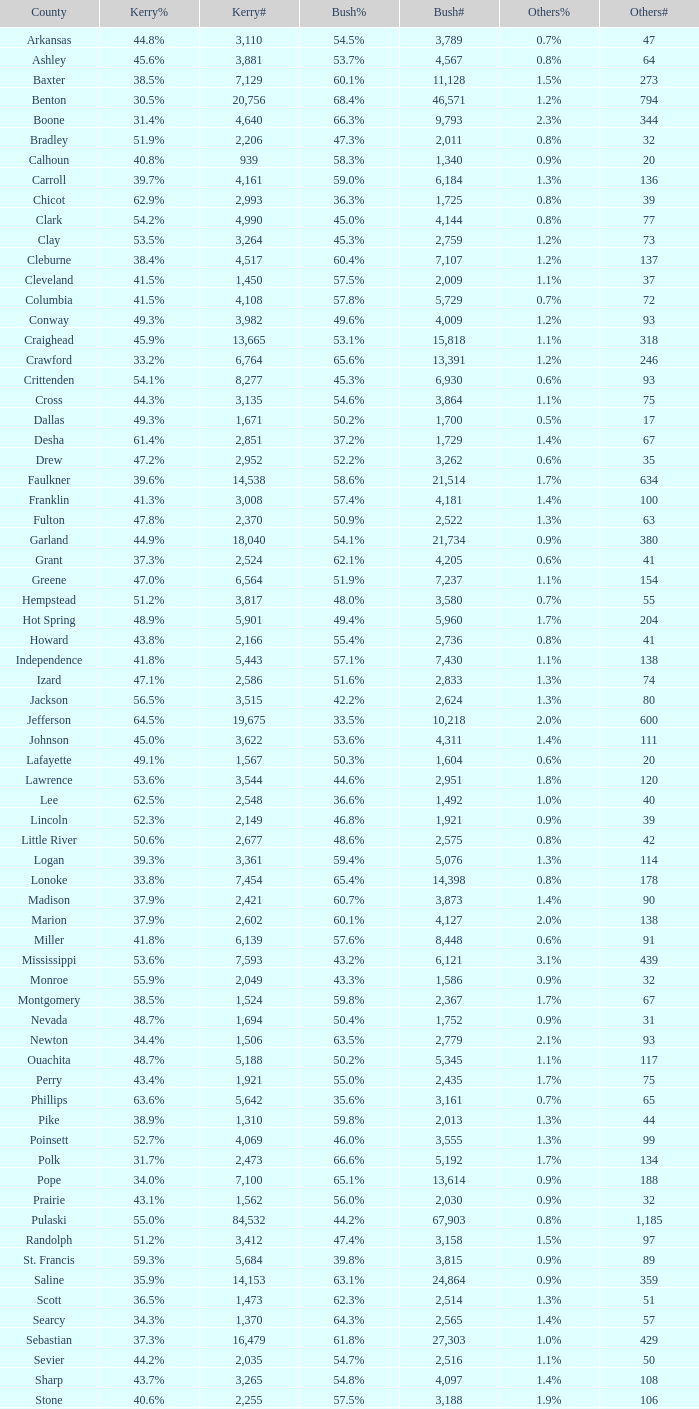Would you mind parsing the complete table? {'header': ['County', 'Kerry%', 'Kerry#', 'Bush%', 'Bush#', 'Others%', 'Others#'], 'rows': [['Arkansas', '44.8%', '3,110', '54.5%', '3,789', '0.7%', '47'], ['Ashley', '45.6%', '3,881', '53.7%', '4,567', '0.8%', '64'], ['Baxter', '38.5%', '7,129', '60.1%', '11,128', '1.5%', '273'], ['Benton', '30.5%', '20,756', '68.4%', '46,571', '1.2%', '794'], ['Boone', '31.4%', '4,640', '66.3%', '9,793', '2.3%', '344'], ['Bradley', '51.9%', '2,206', '47.3%', '2,011', '0.8%', '32'], ['Calhoun', '40.8%', '939', '58.3%', '1,340', '0.9%', '20'], ['Carroll', '39.7%', '4,161', '59.0%', '6,184', '1.3%', '136'], ['Chicot', '62.9%', '2,993', '36.3%', '1,725', '0.8%', '39'], ['Clark', '54.2%', '4,990', '45.0%', '4,144', '0.8%', '77'], ['Clay', '53.5%', '3,264', '45.3%', '2,759', '1.2%', '73'], ['Cleburne', '38.4%', '4,517', '60.4%', '7,107', '1.2%', '137'], ['Cleveland', '41.5%', '1,450', '57.5%', '2,009', '1.1%', '37'], ['Columbia', '41.5%', '4,108', '57.8%', '5,729', '0.7%', '72'], ['Conway', '49.3%', '3,982', '49.6%', '4,009', '1.2%', '93'], ['Craighead', '45.9%', '13,665', '53.1%', '15,818', '1.1%', '318'], ['Crawford', '33.2%', '6,764', '65.6%', '13,391', '1.2%', '246'], ['Crittenden', '54.1%', '8,277', '45.3%', '6,930', '0.6%', '93'], ['Cross', '44.3%', '3,135', '54.6%', '3,864', '1.1%', '75'], ['Dallas', '49.3%', '1,671', '50.2%', '1,700', '0.5%', '17'], ['Desha', '61.4%', '2,851', '37.2%', '1,729', '1.4%', '67'], ['Drew', '47.2%', '2,952', '52.2%', '3,262', '0.6%', '35'], ['Faulkner', '39.6%', '14,538', '58.6%', '21,514', '1.7%', '634'], ['Franklin', '41.3%', '3,008', '57.4%', '4,181', '1.4%', '100'], ['Fulton', '47.8%', '2,370', '50.9%', '2,522', '1.3%', '63'], ['Garland', '44.9%', '18,040', '54.1%', '21,734', '0.9%', '380'], ['Grant', '37.3%', '2,524', '62.1%', '4,205', '0.6%', '41'], ['Greene', '47.0%', '6,564', '51.9%', '7,237', '1.1%', '154'], ['Hempstead', '51.2%', '3,817', '48.0%', '3,580', '0.7%', '55'], ['Hot Spring', '48.9%', '5,901', '49.4%', '5,960', '1.7%', '204'], ['Howard', '43.8%', '2,166', '55.4%', '2,736', '0.8%', '41'], ['Independence', '41.8%', '5,443', '57.1%', '7,430', '1.1%', '138'], ['Izard', '47.1%', '2,586', '51.6%', '2,833', '1.3%', '74'], ['Jackson', '56.5%', '3,515', '42.2%', '2,624', '1.3%', '80'], ['Jefferson', '64.5%', '19,675', '33.5%', '10,218', '2.0%', '600'], ['Johnson', '45.0%', '3,622', '53.6%', '4,311', '1.4%', '111'], ['Lafayette', '49.1%', '1,567', '50.3%', '1,604', '0.6%', '20'], ['Lawrence', '53.6%', '3,544', '44.6%', '2,951', '1.8%', '120'], ['Lee', '62.5%', '2,548', '36.6%', '1,492', '1.0%', '40'], ['Lincoln', '52.3%', '2,149', '46.8%', '1,921', '0.9%', '39'], ['Little River', '50.6%', '2,677', '48.6%', '2,575', '0.8%', '42'], ['Logan', '39.3%', '3,361', '59.4%', '5,076', '1.3%', '114'], ['Lonoke', '33.8%', '7,454', '65.4%', '14,398', '0.8%', '178'], ['Madison', '37.9%', '2,421', '60.7%', '3,873', '1.4%', '90'], ['Marion', '37.9%', '2,602', '60.1%', '4,127', '2.0%', '138'], ['Miller', '41.8%', '6,139', '57.6%', '8,448', '0.6%', '91'], ['Mississippi', '53.6%', '7,593', '43.2%', '6,121', '3.1%', '439'], ['Monroe', '55.9%', '2,049', '43.3%', '1,586', '0.9%', '32'], ['Montgomery', '38.5%', '1,524', '59.8%', '2,367', '1.7%', '67'], ['Nevada', '48.7%', '1,694', '50.4%', '1,752', '0.9%', '31'], ['Newton', '34.4%', '1,506', '63.5%', '2,779', '2.1%', '93'], ['Ouachita', '48.7%', '5,188', '50.2%', '5,345', '1.1%', '117'], ['Perry', '43.4%', '1,921', '55.0%', '2,435', '1.7%', '75'], ['Phillips', '63.6%', '5,642', '35.6%', '3,161', '0.7%', '65'], ['Pike', '38.9%', '1,310', '59.8%', '2,013', '1.3%', '44'], ['Poinsett', '52.7%', '4,069', '46.0%', '3,555', '1.3%', '99'], ['Polk', '31.7%', '2,473', '66.6%', '5,192', '1.7%', '134'], ['Pope', '34.0%', '7,100', '65.1%', '13,614', '0.9%', '188'], ['Prairie', '43.1%', '1,562', '56.0%', '2,030', '0.9%', '32'], ['Pulaski', '55.0%', '84,532', '44.2%', '67,903', '0.8%', '1,185'], ['Randolph', '51.2%', '3,412', '47.4%', '3,158', '1.5%', '97'], ['St. Francis', '59.3%', '5,684', '39.8%', '3,815', '0.9%', '89'], ['Saline', '35.9%', '14,153', '63.1%', '24,864', '0.9%', '359'], ['Scott', '36.5%', '1,473', '62.3%', '2,514', '1.3%', '51'], ['Searcy', '34.3%', '1,370', '64.3%', '2,565', '1.4%', '57'], ['Sebastian', '37.3%', '16,479', '61.8%', '27,303', '1.0%', '429'], ['Sevier', '44.2%', '2,035', '54.7%', '2,516', '1.1%', '50'], ['Sharp', '43.7%', '3,265', '54.8%', '4,097', '1.4%', '108'], ['Stone', '40.6%', '2,255', '57.5%', '3,188', '1.9%', '106'], ['Union', '39.7%', '7,071', '58.9%', '10,502', '1.5%', '259'], ['Van Buren', '44.9%', '3,310', '54.1%', '3,988', '1.0%', '76'], ['Washington', '43.1%', '27,597', '55.7%', '35,726', '1.2%', '780'], ['White', '34.5%', '9,129', '64.3%', '17,001', '1.1%', '295'], ['Woodruff', '65.2%', '1,972', '33.7%', '1,021', '1.1%', '33'], ['Yell', '43.7%', '2,913', '55.2%', '3,678', '1.0%', '68']]} What is the lowest Bush#, when Bush% is "65.4%"? 14398.0. 